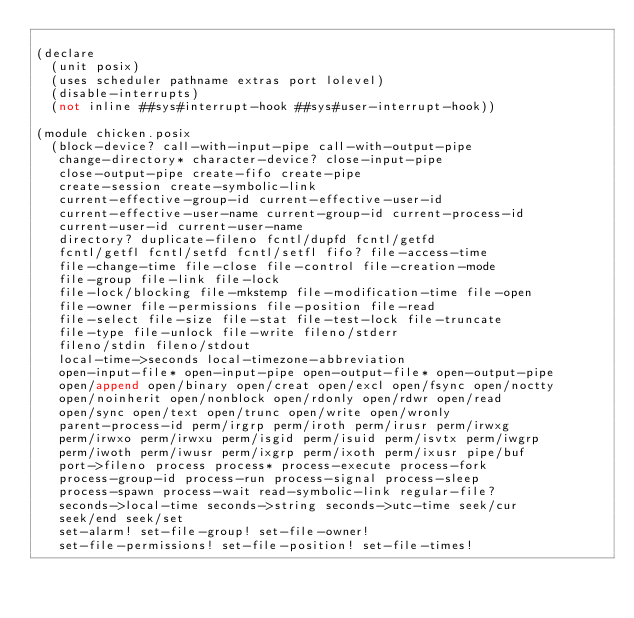Convert code to text. <code><loc_0><loc_0><loc_500><loc_500><_Scheme_>
(declare
  (unit posix)
  (uses scheduler pathname extras port lolevel)
  (disable-interrupts)
  (not inline ##sys#interrupt-hook ##sys#user-interrupt-hook))

(module chicken.posix
  (block-device? call-with-input-pipe call-with-output-pipe
   change-directory* character-device? close-input-pipe
   close-output-pipe create-fifo create-pipe
   create-session create-symbolic-link
   current-effective-group-id current-effective-user-id
   current-effective-user-name current-group-id current-process-id
   current-user-id current-user-name
   directory? duplicate-fileno fcntl/dupfd fcntl/getfd
   fcntl/getfl fcntl/setfd fcntl/setfl fifo? file-access-time
   file-change-time file-close file-control file-creation-mode
   file-group file-link file-lock
   file-lock/blocking file-mkstemp file-modification-time file-open
   file-owner file-permissions file-position file-read
   file-select file-size file-stat file-test-lock file-truncate
   file-type file-unlock file-write fileno/stderr
   fileno/stdin fileno/stdout
   local-time->seconds local-timezone-abbreviation
   open-input-file* open-input-pipe open-output-file* open-output-pipe
   open/append open/binary open/creat open/excl open/fsync open/noctty
   open/noinherit open/nonblock open/rdonly open/rdwr open/read
   open/sync open/text open/trunc open/write open/wronly
   parent-process-id perm/irgrp perm/iroth perm/irusr perm/irwxg
   perm/irwxo perm/irwxu perm/isgid perm/isuid perm/isvtx perm/iwgrp
   perm/iwoth perm/iwusr perm/ixgrp perm/ixoth perm/ixusr pipe/buf
   port->fileno process process* process-execute process-fork
   process-group-id process-run process-signal process-sleep
   process-spawn process-wait read-symbolic-link regular-file?
   seconds->local-time seconds->string seconds->utc-time seek/cur
   seek/end seek/set
   set-alarm! set-file-group! set-file-owner!
   set-file-permissions! set-file-position! set-file-times!</code> 